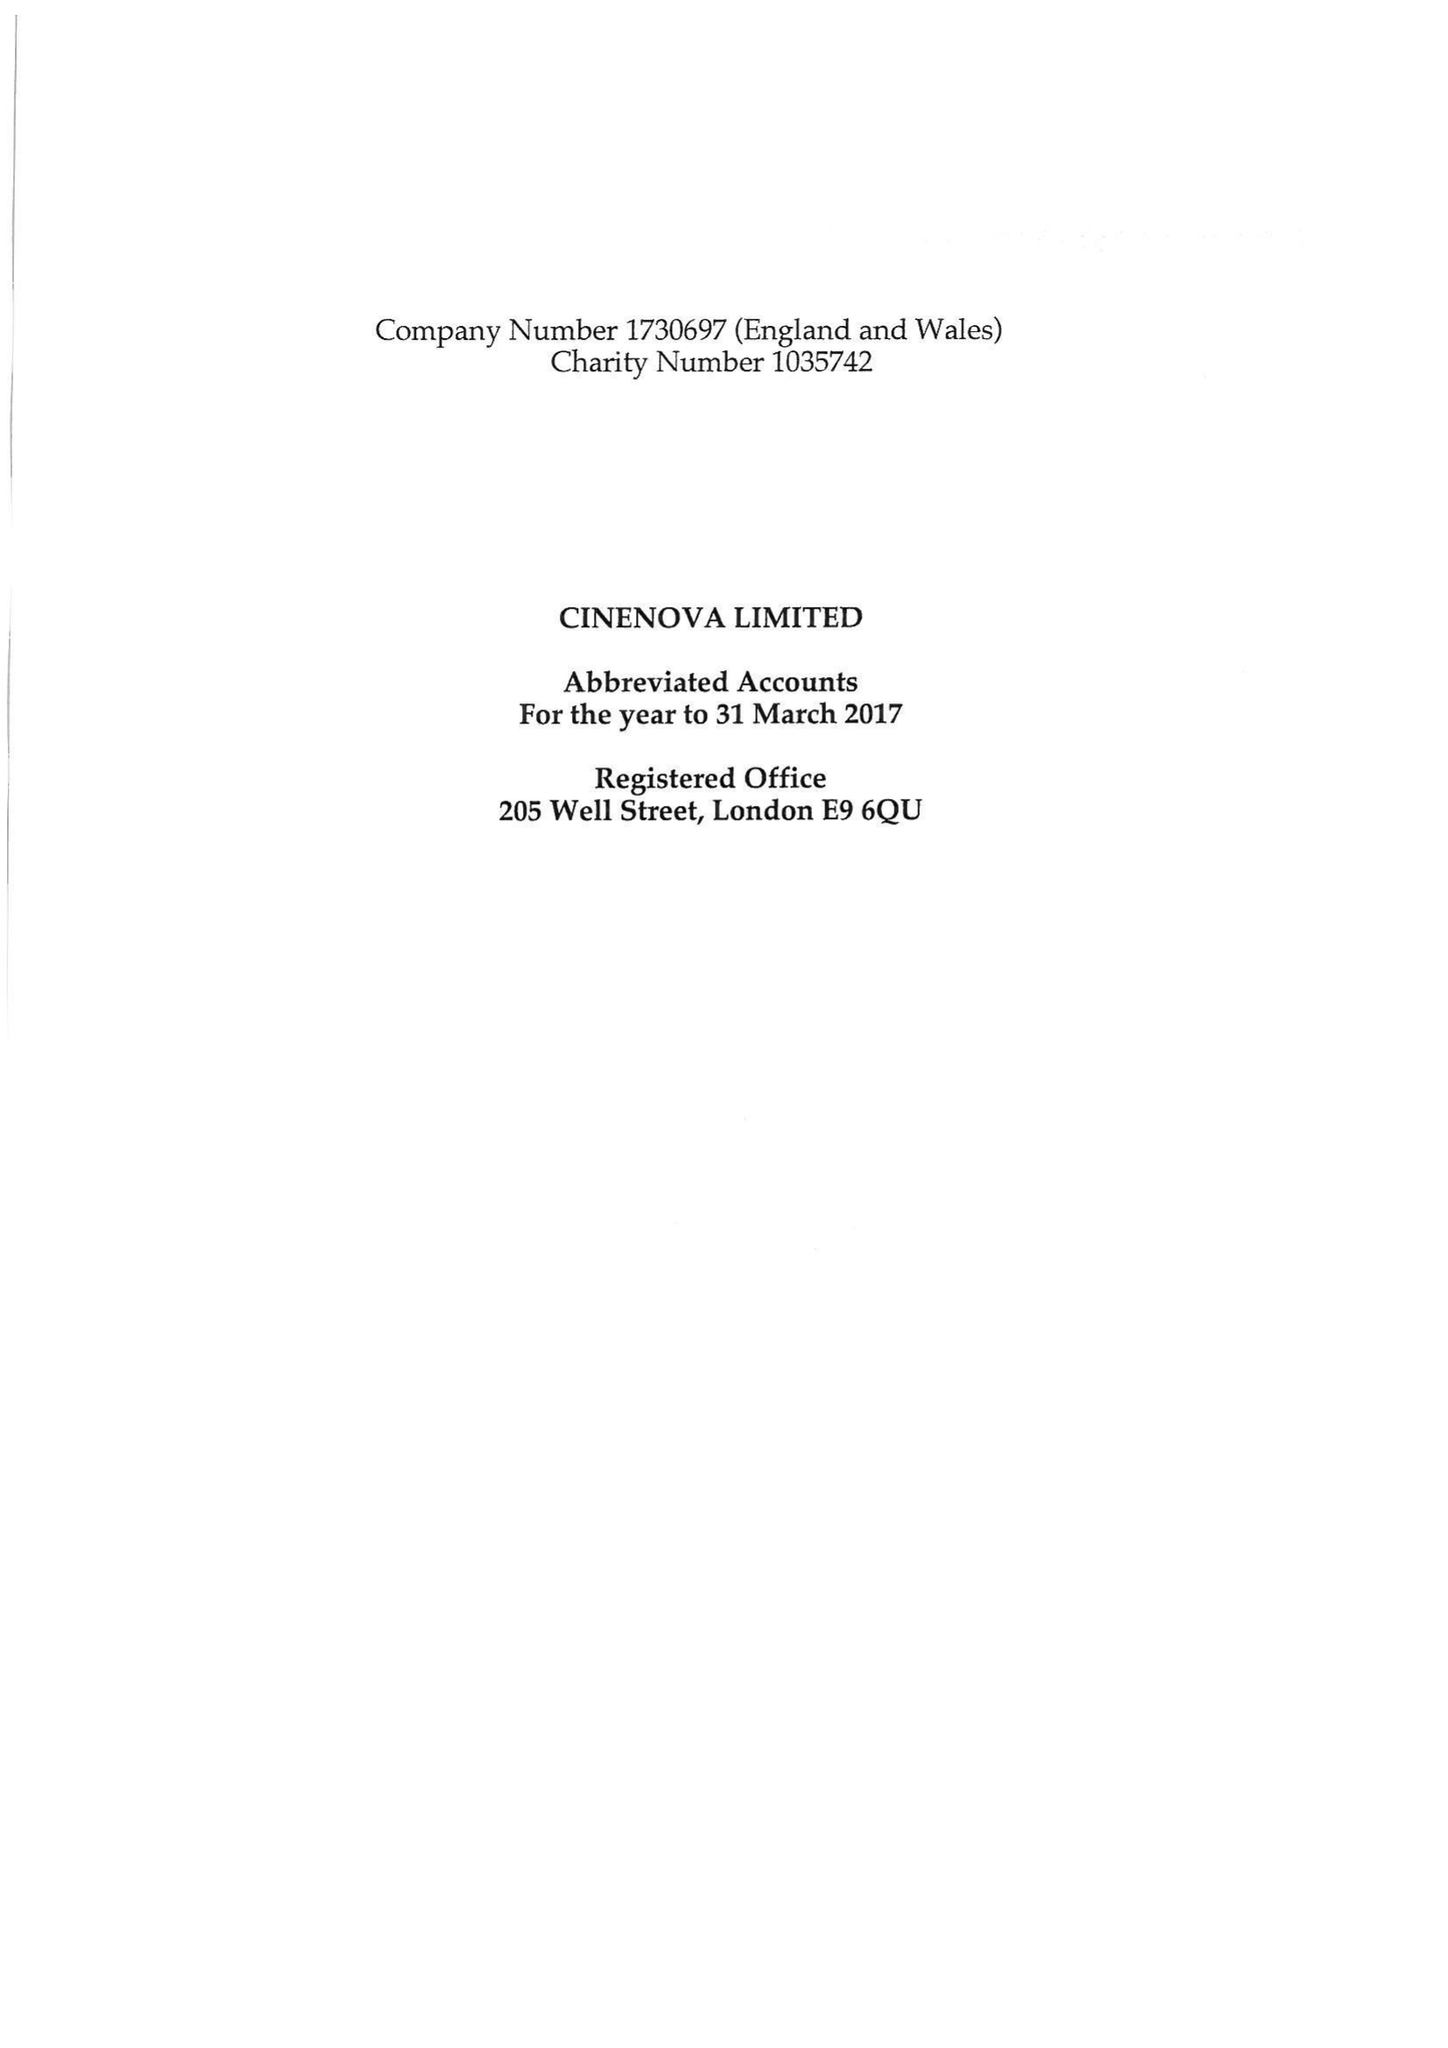What is the value for the address__postcode?
Answer the question using a single word or phrase. N19 5JF 